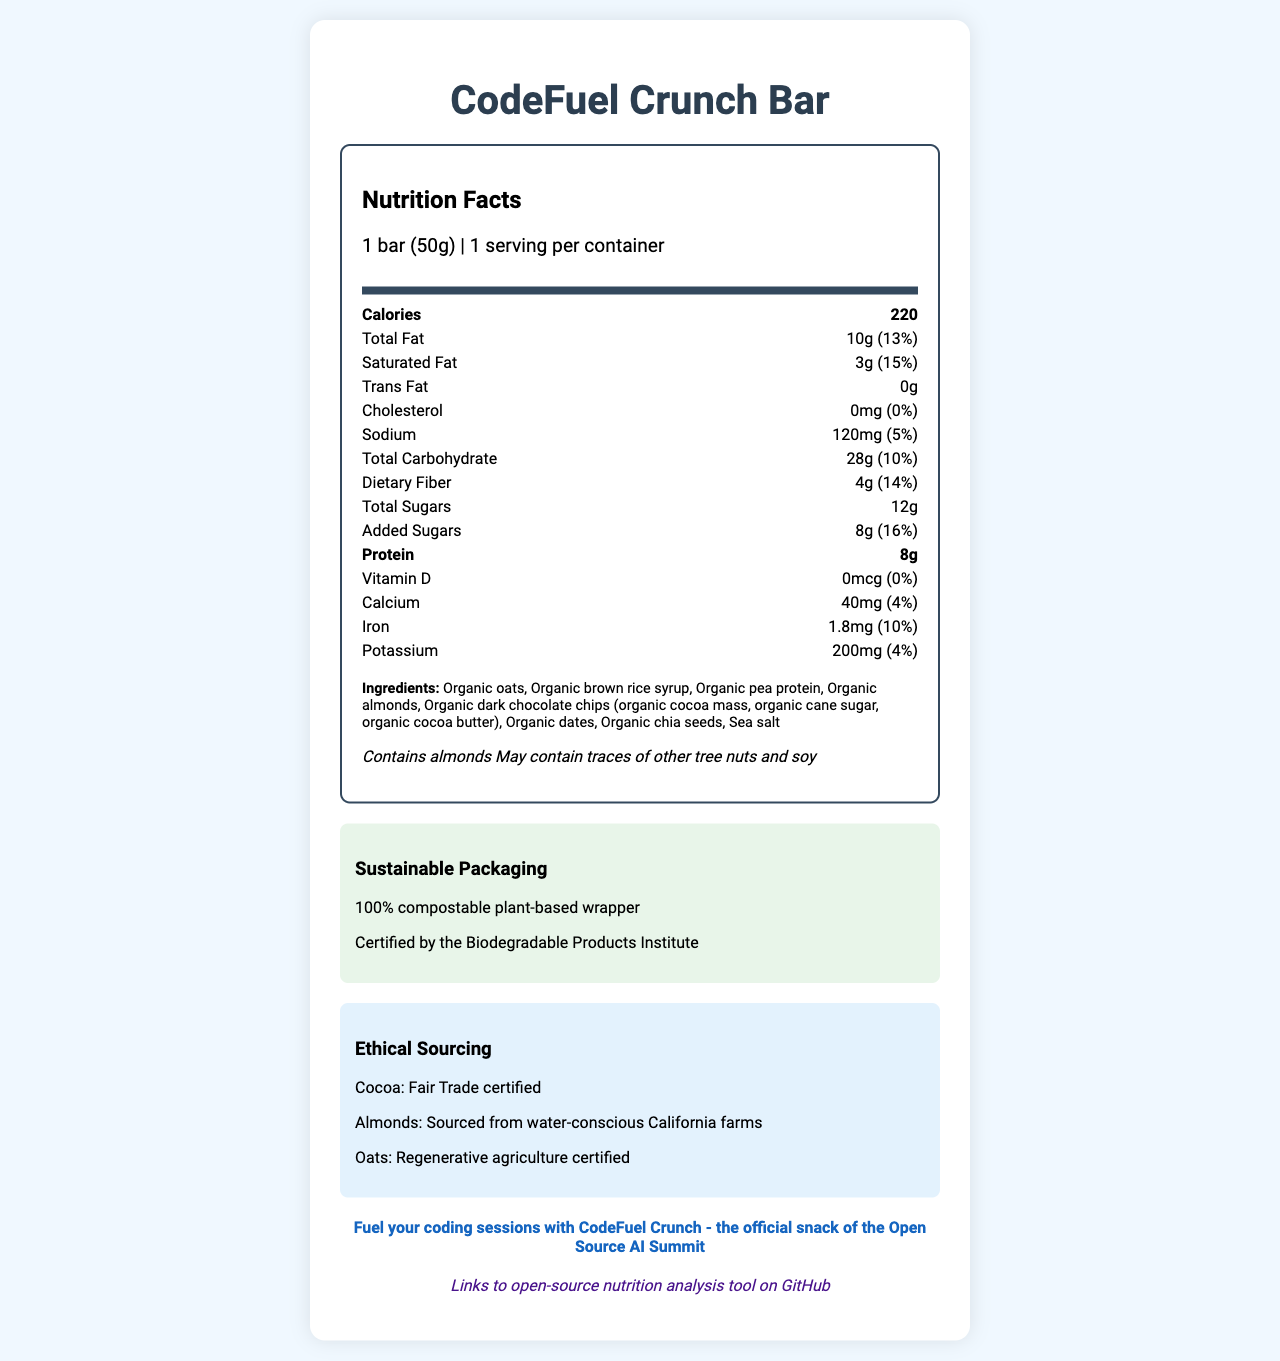what is the serving size of the CodeFuel Crunch Bar? The serving size is mentioned at the top of the nutrition facts section.
Answer: 1 bar (50g) what percentage of the daily value of saturated fat does the CodeFuel Crunch Bar contain? The saturated fat information in the nutrition label indicates it provides 15% of the daily value.
Answer: 15% how many grams of dietary fiber are in the CodeFuel Crunch Bar? The nutrition facts label lists dietary fiber as 4 grams.
Answer: 4g what material is used for the packaging of the CodeFuel Crunch Bar? The document states the wrapper is made from 100% compostable plant-based material.
Answer: 100% compostable plant-based wrapper which ingredient is NOT included in the CodeFuel Crunch Bar? A. Organic dates B. Organic raisins C. Organic chia seeds The list of ingredients contains organic dates and organic chia seeds but not organic raisins.
Answer: B how many servings are there per container of the CodeFuel Crunch Bar? The document mentions that there is 1 serving per container.
Answer: 1 is the sodium content in the CodeFuel Crunch Bar high or low in terms of daily value percentage? The sodium content is listed as 120mg, which is 5% of the daily value, a relatively low percentage.
Answer: Low (5%) is the product gluten-free? The document does not provide information on whether the product is gluten-free.
Answer: Not enough information what allergens does the CodeFuel Crunch Bar potentially contain? The allergen information specifies almonds and possible traces of other tree nuts and soy.
Answer: Contains almonds, may contain traces of other tree nuts and soy how many calories are there in a CodeFuel Crunch Bar? The caloric content is listed as 220 calories in the nutrition facts label.
Answer: 220 calories how is the cocoa sourced for the CodeFuel Crunch Bar? A. Free Trade certified B. Fair Trade certified C. Rainforest Alliance certified The document states the cocoa is Fair Trade certified.
Answer: B does the CodeFuel Crunch Bar contain any added sugars? The nutrition facts clearly state that the bar contains 8 grams of added sugars.
Answer: Yes does the CodeFuel Crunch Bar contain any cholesterol? The label shows "0mg" of cholesterol, with a daily value of 0%.
Answer: No can you find the link to an open-source nutrition analysis tool in the document? The QR code in the document links to an open-source nutrition analysis tool on GitHub.
Answer: Yes summarize the main idea of the entire document The document gives a comprehensive view of the CodeFuel Crunch Bar, highlighting its nutritional value, ingredients, allergens, sustainable packaging, ethical sourcing, and connection to an open-source tool.
Answer: The document is the nutrition facts label for the "CodeFuel Crunch Bar." It provides detailed nutrition information, including calorie count, fat, carbohydrate, fiber, sugar, and protein content. Ingredients list, allergen information, sustainable packaging details, and ethical sourcing information are also provided. The product is promoted with a focus on sustainable and ethical practices, with an open-source nutrition analysis tool accessible via a QR code. 